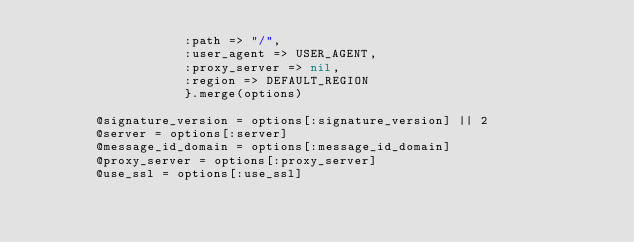Convert code to text. <code><loc_0><loc_0><loc_500><loc_500><_Ruby_>                    :path => "/",
                    :user_agent => USER_AGENT,
                    :proxy_server => nil,
                    :region => DEFAULT_REGION
                    }.merge(options)

        @signature_version = options[:signature_version] || 2
        @server = options[:server]
        @message_id_domain = options[:message_id_domain]
        @proxy_server = options[:proxy_server]
        @use_ssl = options[:use_ssl]</code> 